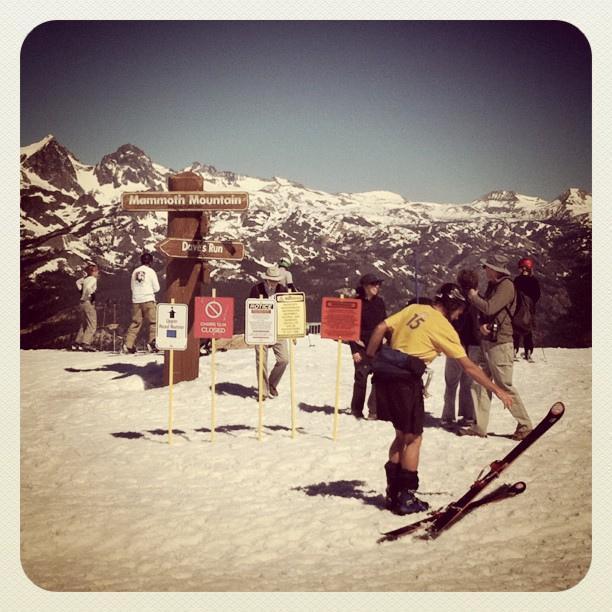Why is the man in the yellow shirt on the mountain?
Select the correct answer and articulate reasoning with the following format: 'Answer: answer
Rationale: rationale.'
Options: To hike, to eat, to ski, to sleep. Answer: to ski.
Rationale: He is placing them on the snow 